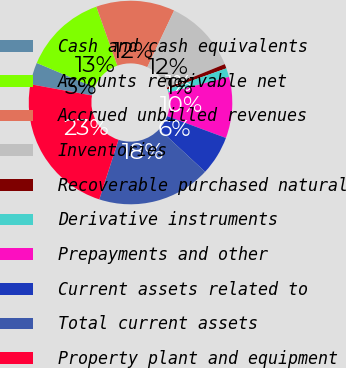Convert chart. <chart><loc_0><loc_0><loc_500><loc_500><pie_chart><fcel>Cash and cash equivalents<fcel>Accounts receivable net<fcel>Accrued unbilled revenues<fcel>Inventories<fcel>Recoverable purchased natural<fcel>Derivative instruments<fcel>Prepayments and other<fcel>Current assets related to<fcel>Total current assets<fcel>Property plant and equipment<nl><fcel>3.48%<fcel>13.19%<fcel>12.5%<fcel>11.8%<fcel>0.7%<fcel>1.4%<fcel>9.72%<fcel>6.25%<fcel>18.05%<fcel>22.91%<nl></chart> 